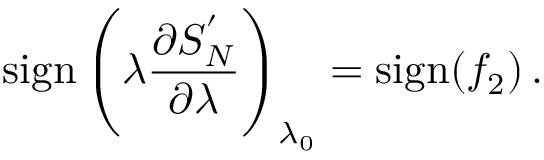<formula> <loc_0><loc_0><loc_500><loc_500>s i g n \left ( \lambda { \frac { \partial S _ { N } ^ { ^ { \prime } } } { \partial \lambda } } \right ) _ { \lambda _ { 0 } } = s i g n ( f _ { 2 } ) \, .</formula> 